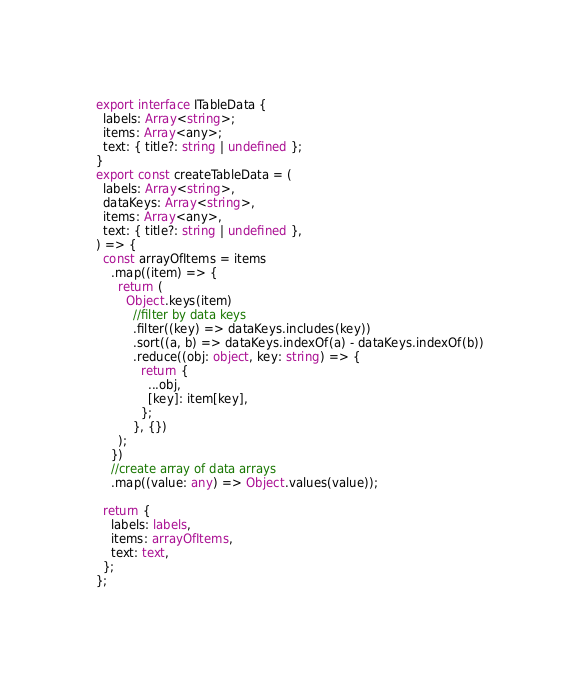<code> <loc_0><loc_0><loc_500><loc_500><_TypeScript_>export interface ITableData {
  labels: Array<string>;
  items: Array<any>;
  text: { title?: string | undefined };
}
export const createTableData = (
  labels: Array<string>,
  dataKeys: Array<string>,
  items: Array<any>,
  text: { title?: string | undefined },
) => {
  const arrayOfItems = items
    .map((item) => {
      return (
        Object.keys(item)
          //filter by data keys
          .filter((key) => dataKeys.includes(key))
          .sort((a, b) => dataKeys.indexOf(a) - dataKeys.indexOf(b))
          .reduce((obj: object, key: string) => {
            return {
              ...obj,
              [key]: item[key],
            };
          }, {})
      );
    })
    //create array of data arrays
    .map((value: any) => Object.values(value));

  return {
    labels: labels,
    items: arrayOfItems,
    text: text,
  };
};
</code> 